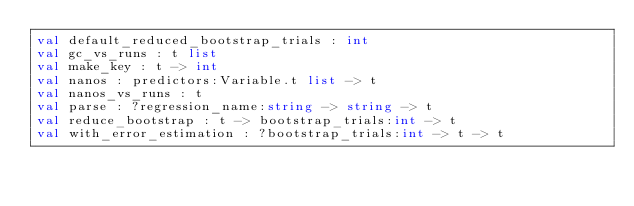Convert code to text. <code><loc_0><loc_0><loc_500><loc_500><_OCaml_>val default_reduced_bootstrap_trials : int
val gc_vs_runs : t list
val make_key : t -> int
val nanos : predictors:Variable.t list -> t
val nanos_vs_runs : t
val parse : ?regression_name:string -> string -> t
val reduce_bootstrap : t -> bootstrap_trials:int -> t
val with_error_estimation : ?bootstrap_trials:int -> t -> t
</code> 